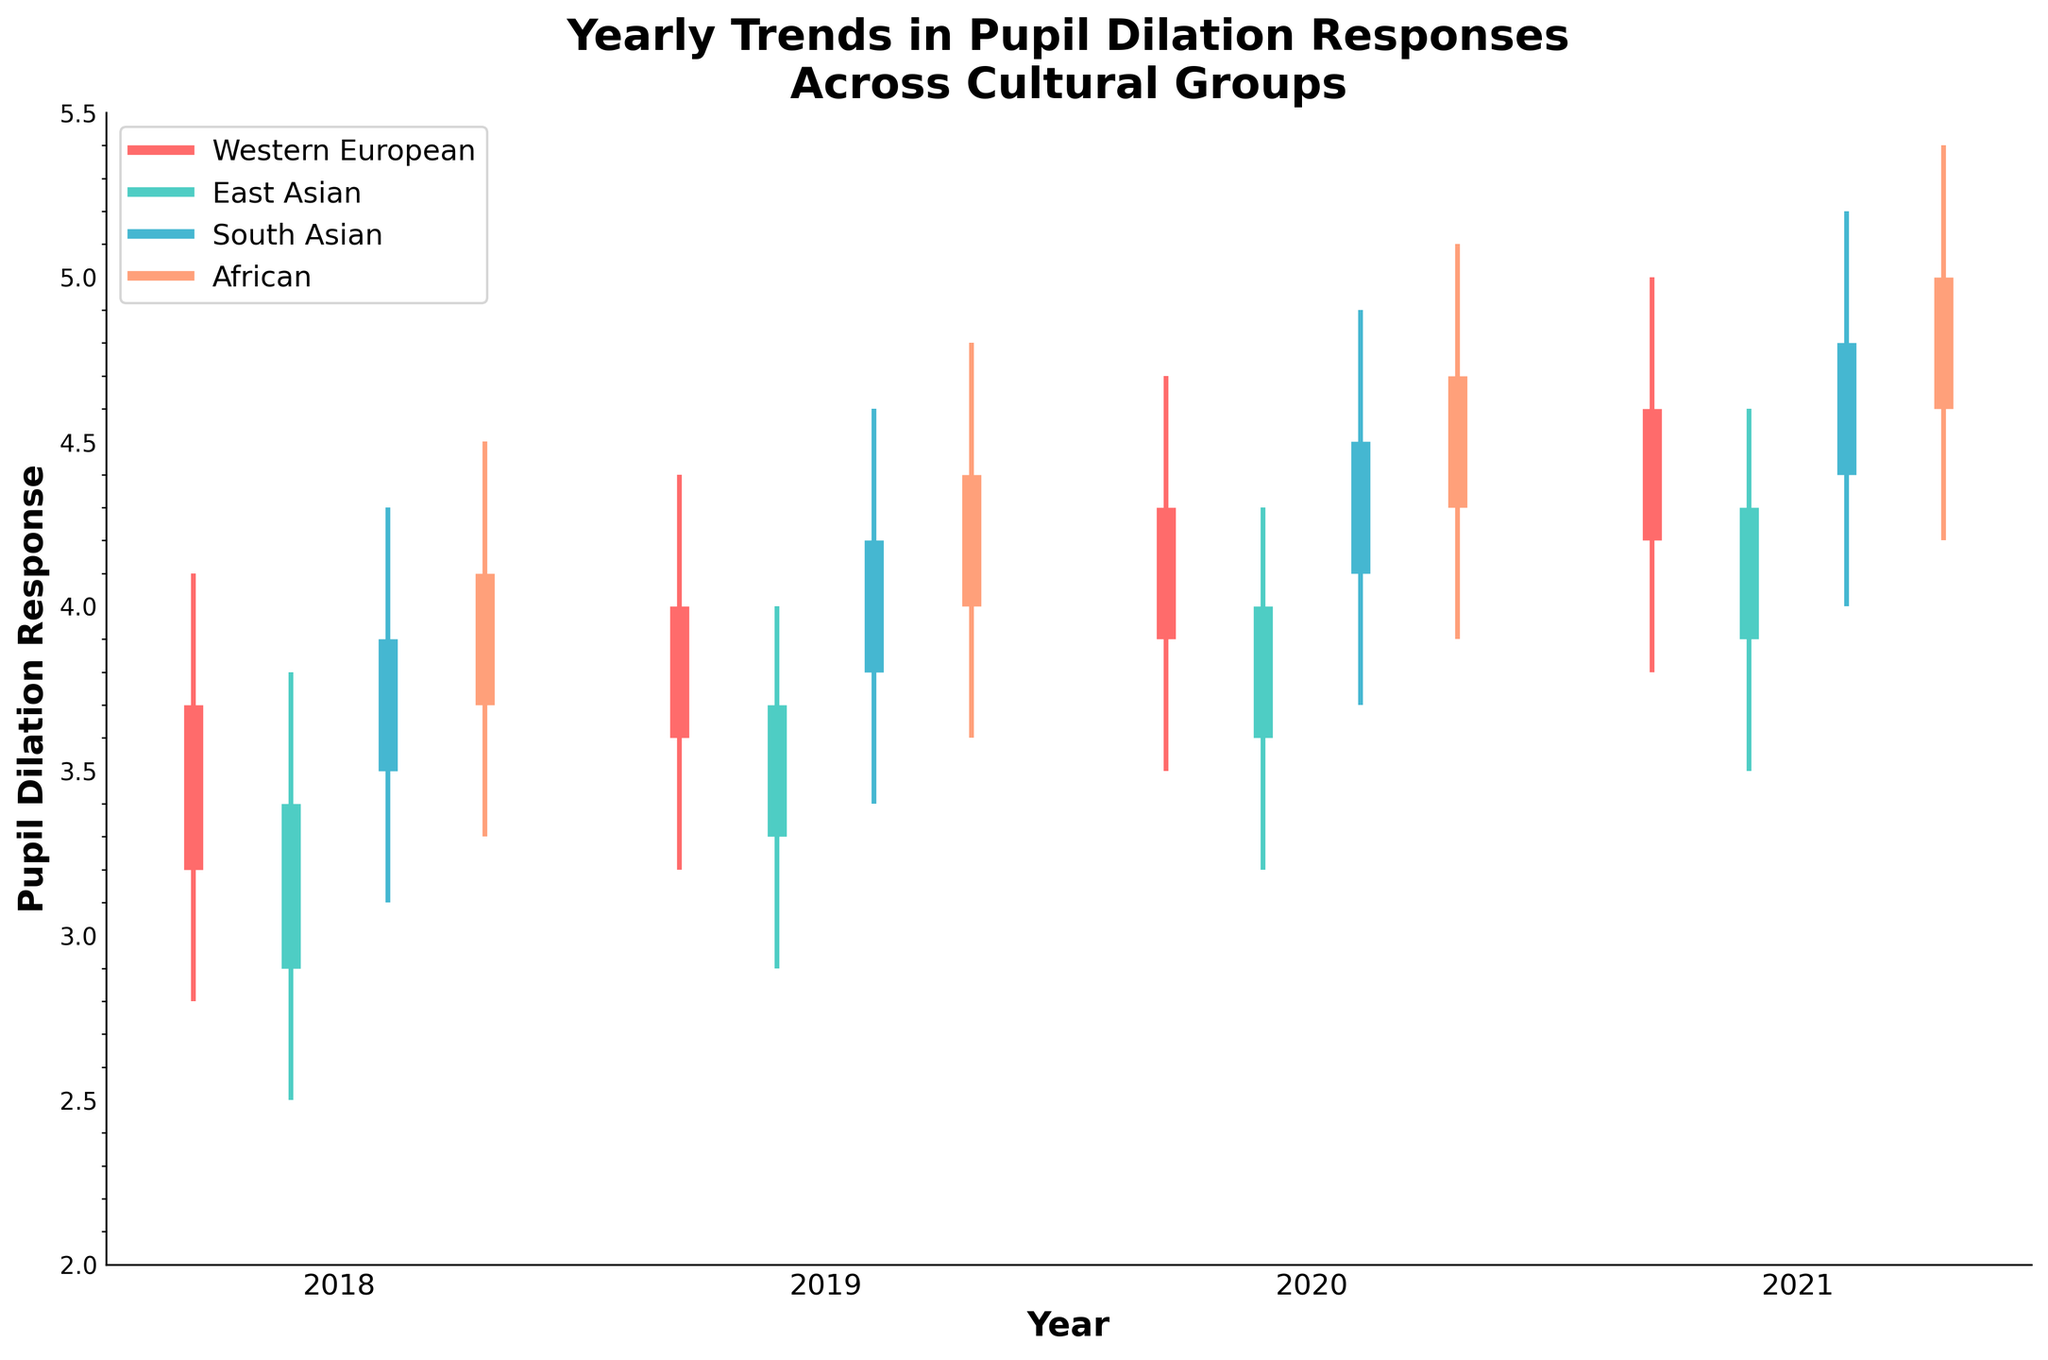What is the title of the figure? The title of the figure is usually at the top and sets the context for the dataset being visualized. In this case, it's clearly specified as 'Yearly Trends in Pupil Dilation Responses Across Cultural Groups'.
Answer: Yearly Trends in Pupil Dilation Responses Across Cultural Groups What years are represented on the x-axis? The x-axis typically represents time or categories and here it shows the label 'Year', with tick values indicating the specific years. One can clearly see the years 2018, 2019, 2020, and 2021 listed.
Answer: 2018, 2019, 2020, 2021 For the year 2021, which cultural group had the highest close value? The 'close' value represents the pupil dilation response at the end of the year. Comparing the 'close' values for the year 2021, the group with the highest value is the African group with a close value of 5.0.
Answer: African What is the range of pupil dilation responses for East Asian cultural group in 2020? The range is calculated by subtracting the 'low' value from the 'high' value. For the East Asian group in 2020, this is 4.3 - 3.2 = 1.1
Answer: 1.1 Which cultural group showed the most consistent (smallest range) response across the four years? Consistency in this context can be gauged by looking at the range (difference between 'high' and 'low') for each group across the years. Western European culture shows relatively consistent range values compared to the others, indicating smaller fluctuations.
Answer: Western European What overall trend in pupil dilation responses can be observed for the South Asian cultural group from 2018 to 2021? The trend can be identified by observing the 'close' values for each year. Starting from 3.9 in 2018, the South Asian group's values increase yearly, reaching 4.8 in 2021, indicating a general upward trend.
Answer: Increase Considering the 'open' values, describe how the starting pupil dilation responses change over the years for the Western European cultural group. For the Western European group, starting values ('open') increase over the years: 3.2 in 2018, 3.6 in 2019, 3.9 in 2020, and 4.2 in 2021, reflecting a steady rise.
Answer: Steady rise Compare the average of the 'close' values in 2019 for all cultural groups. Which had the highest average? Summing the close values for each group in 2019: 4.0 (Western European), 3.7 (East Asian), 4.2 (South Asian), and 4.4 (African), then averaging: (4.0 + 3.7 + 4.2 + 4.4) / 4 = 4.075. African group has the highest individual close value (4.4), contributing significantly to the high average.
Answer: African What color represents the East Asian cultural group in the plot? Colors are used to differentiate cultural groups, and each is associated with a specific color. For East Asian, the plot uses a distinctive greenish color.
Answer: Green 